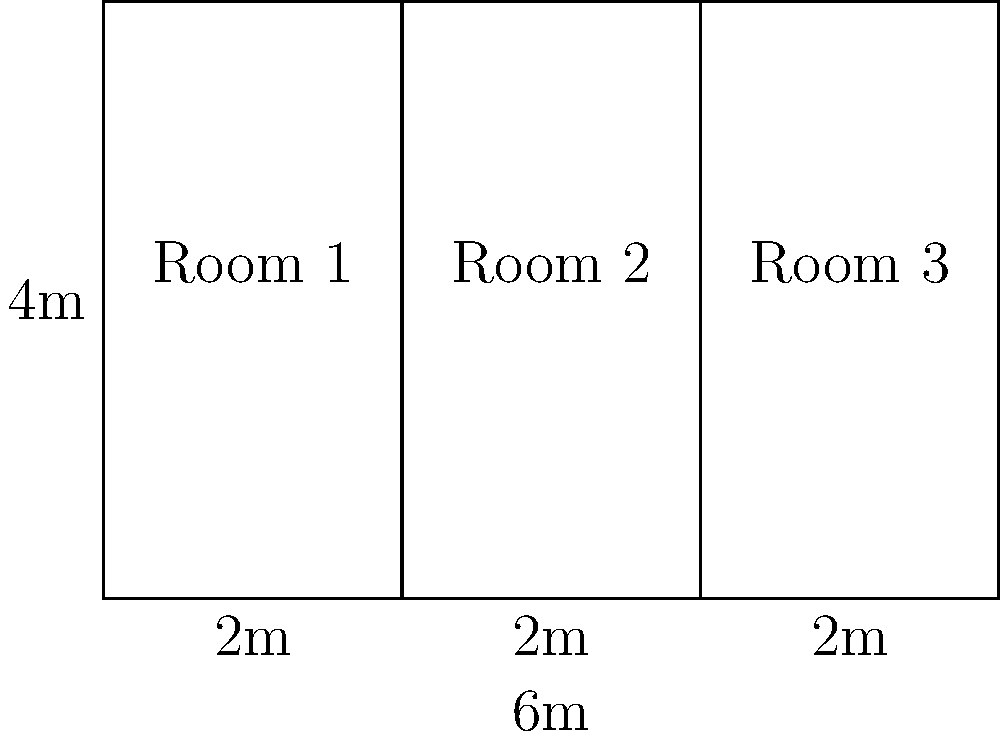In a public housing floor plan, three rectangular rooms are arranged side by side as shown. If the total width of the layout is 6 meters and the height is 4 meters, what is the area of each room in square meters? Assume all rooms have the same width. Let's approach this step-by-step:

1) First, we need to determine the width of each room:
   - The total width is 6 meters
   - There are 3 rooms of equal width
   - So, the width of each room is: $6 \div 3 = 2$ meters

2) We're given that the height of the layout is 4 meters. This is also the height of each room.

3) Now, we can calculate the area of each room:
   - Area of a rectangle = length × width
   - Area = $4 \text{ meters} \times 2 \text{ meters} = 8 \text{ square meters}$

4) We can verify this by calculating the total area:
   - Total area = $6 \text{ meters} \times 4 \text{ meters} = 24 \text{ square meters}$
   - Area of three rooms = $3 \times 8 \text{ square meters} = 24 \text{ square meters}$

Therefore, each room has an area of 8 square meters.
Answer: 8 square meters 